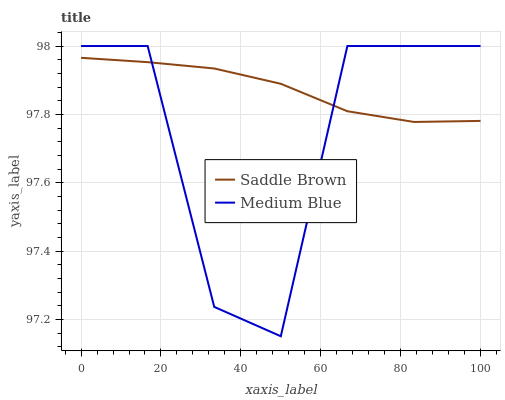Does Medium Blue have the minimum area under the curve?
Answer yes or no. Yes. Does Saddle Brown have the maximum area under the curve?
Answer yes or no. Yes. Does Saddle Brown have the minimum area under the curve?
Answer yes or no. No. Is Saddle Brown the smoothest?
Answer yes or no. Yes. Is Medium Blue the roughest?
Answer yes or no. Yes. Is Saddle Brown the roughest?
Answer yes or no. No. Does Medium Blue have the lowest value?
Answer yes or no. Yes. Does Saddle Brown have the lowest value?
Answer yes or no. No. Does Medium Blue have the highest value?
Answer yes or no. Yes. Does Saddle Brown have the highest value?
Answer yes or no. No. Does Medium Blue intersect Saddle Brown?
Answer yes or no. Yes. Is Medium Blue less than Saddle Brown?
Answer yes or no. No. Is Medium Blue greater than Saddle Brown?
Answer yes or no. No. 